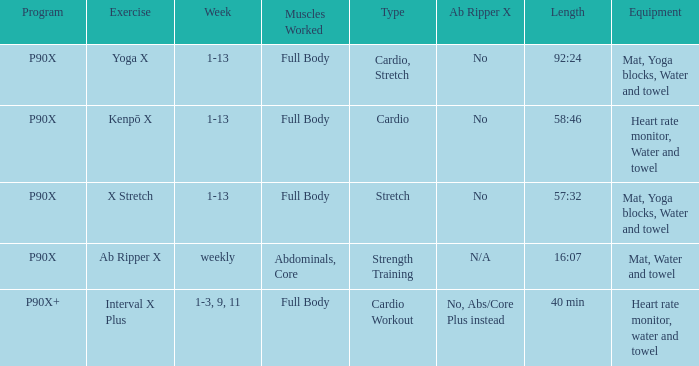What is the ab ripper x when the length is 92:24? No. 